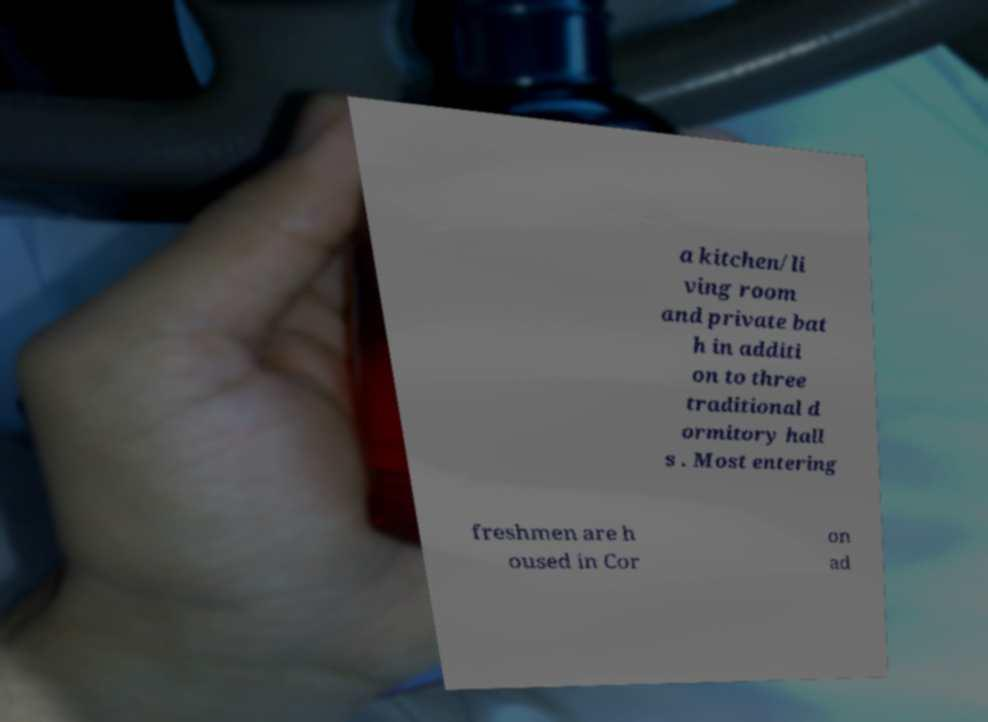Please identify and transcribe the text found in this image. a kitchen/li ving room and private bat h in additi on to three traditional d ormitory hall s . Most entering freshmen are h oused in Cor on ad 